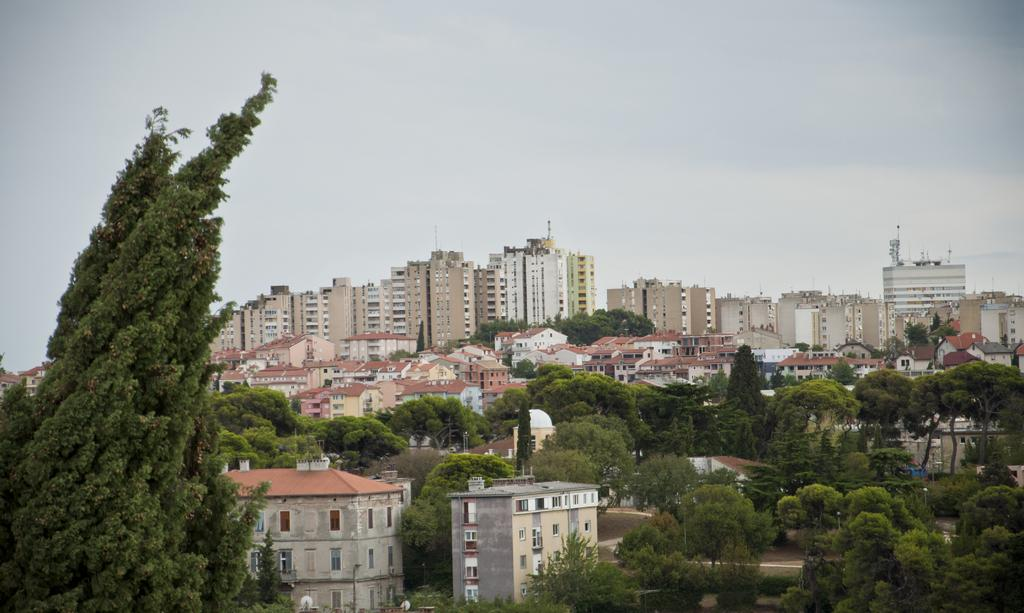What type of location is depicted in the image? The image is of a city. What can be seen in the foreground of the image? There are trees and buildings in the foreground of the image. What is the condition of the sky in the image? The sky is cloudy in the image. What type of chain can be seen connecting the buildings in the image? There is no chain connecting the buildings in the image; the buildings are separate structures. What type of learning is taking place in the image? There is no learning activity depicted in the image; it is a cityscape with trees, buildings, and a cloudy sky. 